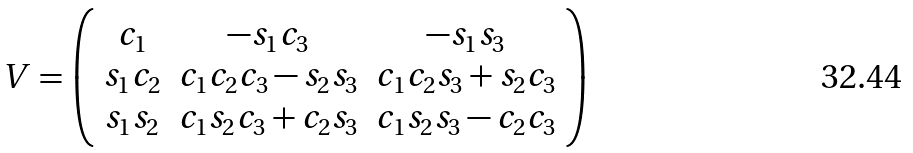Convert formula to latex. <formula><loc_0><loc_0><loc_500><loc_500>V = \left ( \begin{array} { c c c } c _ { 1 } & - s _ { 1 } c _ { 3 } & - s _ { 1 } s _ { 3 } \\ s _ { 1 } c _ { 2 } & c _ { 1 } c _ { 2 } c _ { 3 } - s _ { 2 } s _ { 3 } & c _ { 1 } c _ { 2 } s _ { 3 } + s _ { 2 } c _ { 3 } \\ s _ { 1 } s _ { 2 } & c _ { 1 } s _ { 2 } c _ { 3 } + c _ { 2 } s _ { 3 } & c _ { 1 } s _ { 2 } s _ { 3 } - c _ { 2 } c _ { 3 } \end{array} \right )</formula> 